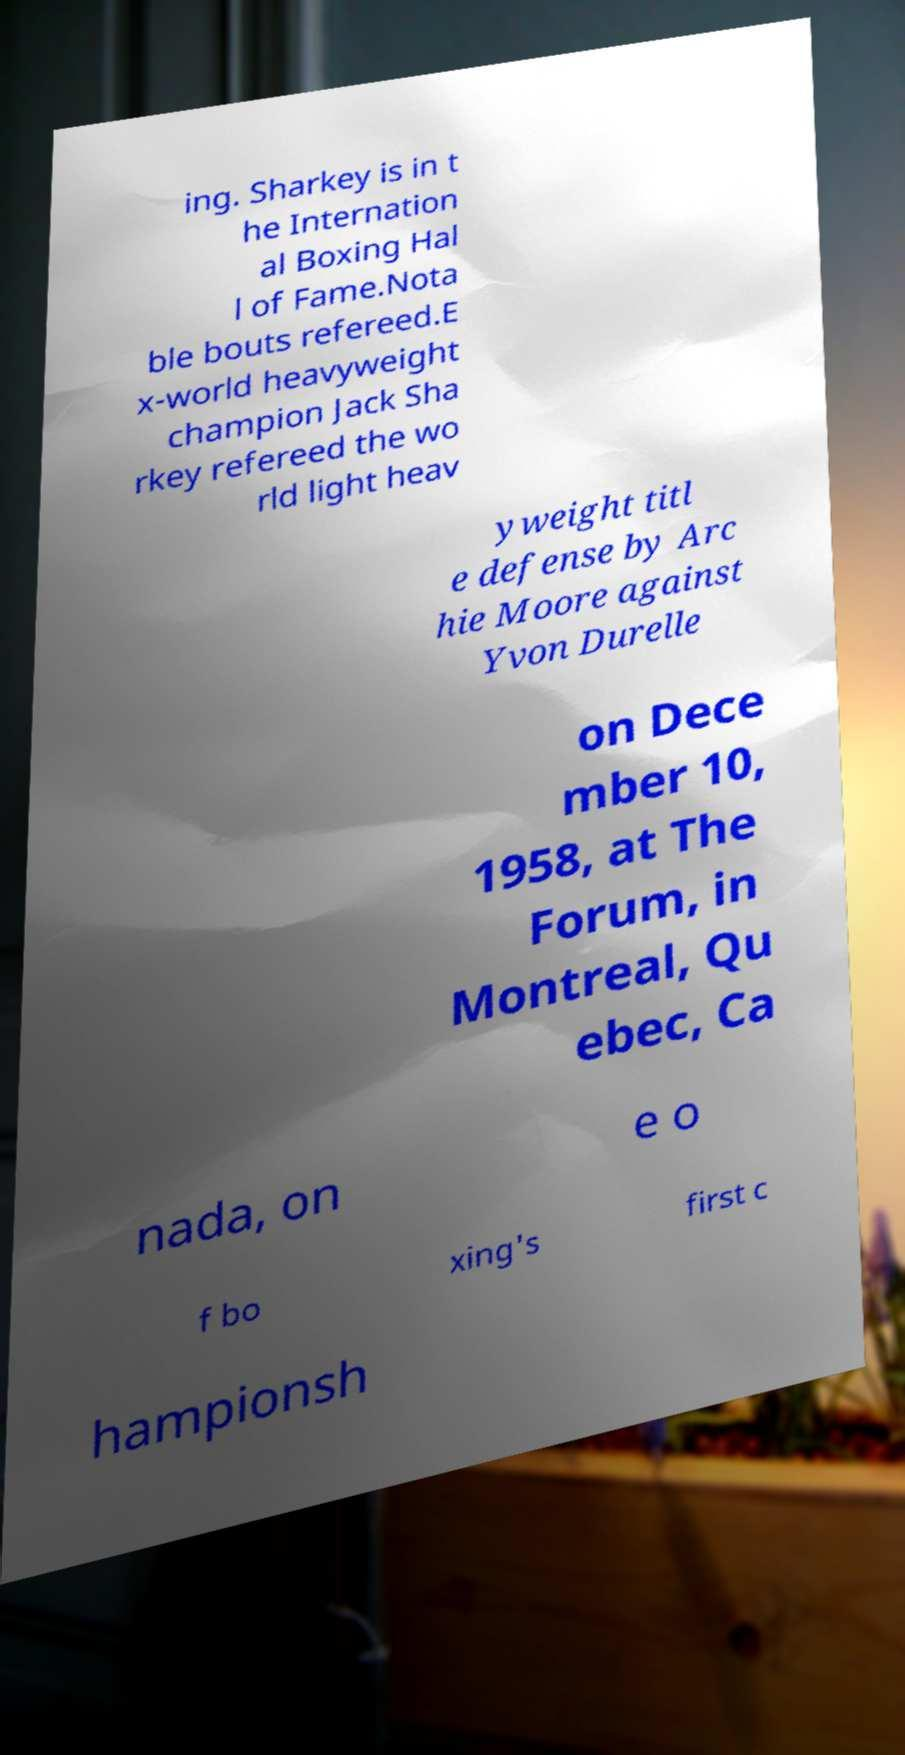For documentation purposes, I need the text within this image transcribed. Could you provide that? ing. Sharkey is in t he Internation al Boxing Hal l of Fame.Nota ble bouts refereed.E x-world heavyweight champion Jack Sha rkey refereed the wo rld light heav yweight titl e defense by Arc hie Moore against Yvon Durelle on Dece mber 10, 1958, at The Forum, in Montreal, Qu ebec, Ca nada, on e o f bo xing's first c hampionsh 